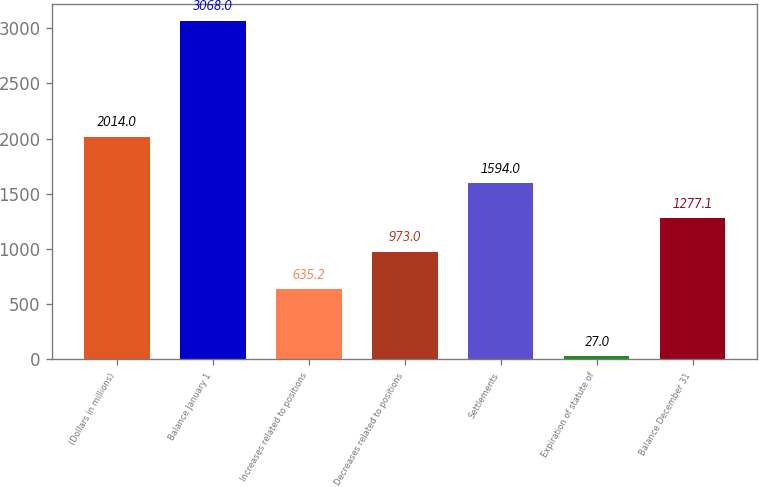Convert chart. <chart><loc_0><loc_0><loc_500><loc_500><bar_chart><fcel>(Dollars in millions)<fcel>Balance January 1<fcel>Increases related to positions<fcel>Decreases related to positions<fcel>Settlements<fcel>Expiration of statute of<fcel>Balance December 31<nl><fcel>2014<fcel>3068<fcel>635.2<fcel>973<fcel>1594<fcel>27<fcel>1277.1<nl></chart> 